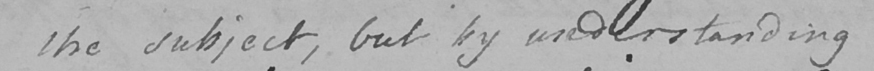What is written in this line of handwriting? the subject , but by understanding 